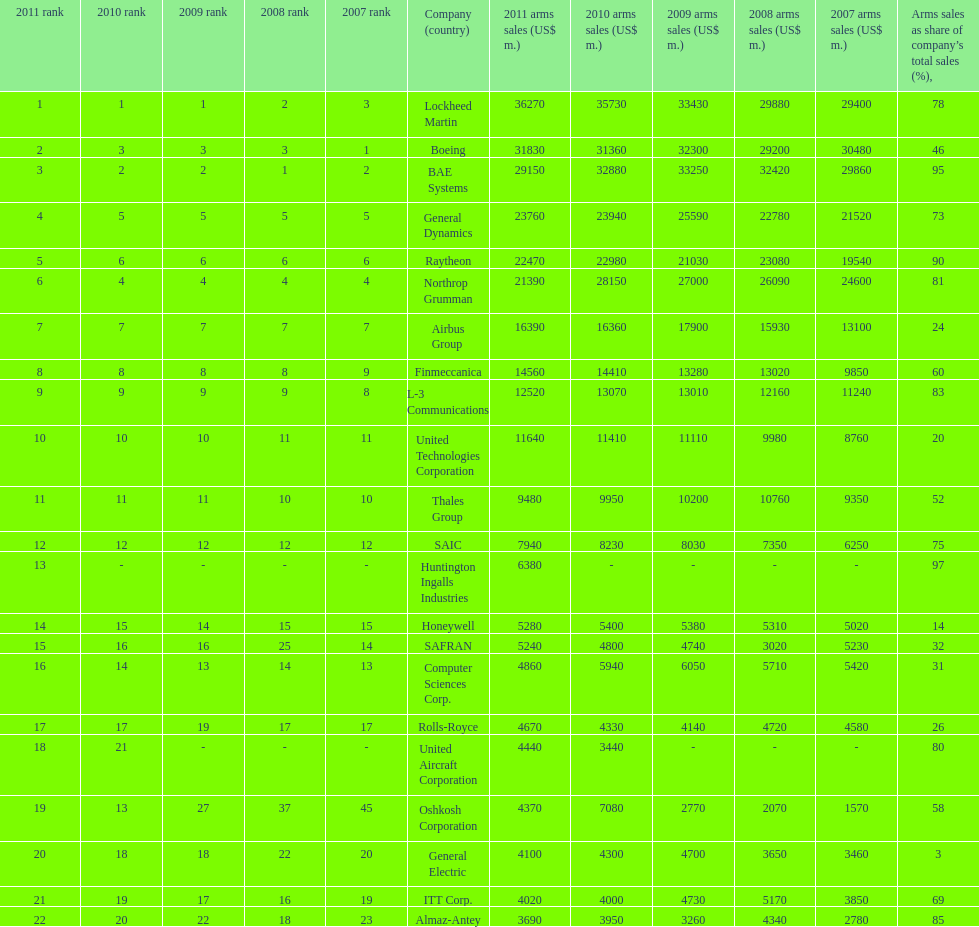Who had the minimum sales in 2010? United Aircraft Corporation. Could you help me parse every detail presented in this table? {'header': ['2011 rank', '2010 rank', '2009 rank', '2008 rank', '2007 rank', 'Company (country)', '2011 arms sales (US$ m.)', '2010 arms sales (US$ m.)', '2009 arms sales (US$ m.)', '2008 arms sales (US$ m.)', '2007 arms sales (US$ m.)', 'Arms sales as share of company’s total sales (%),'], 'rows': [['1', '1', '1', '2', '3', 'Lockheed Martin', '36270', '35730', '33430', '29880', '29400', '78'], ['2', '3', '3', '3', '1', 'Boeing', '31830', '31360', '32300', '29200', '30480', '46'], ['3', '2', '2', '1', '2', 'BAE Systems', '29150', '32880', '33250', '32420', '29860', '95'], ['4', '5', '5', '5', '5', 'General Dynamics', '23760', '23940', '25590', '22780', '21520', '73'], ['5', '6', '6', '6', '6', 'Raytheon', '22470', '22980', '21030', '23080', '19540', '90'], ['6', '4', '4', '4', '4', 'Northrop Grumman', '21390', '28150', '27000', '26090', '24600', '81'], ['7', '7', '7', '7', '7', 'Airbus Group', '16390', '16360', '17900', '15930', '13100', '24'], ['8', '8', '8', '8', '9', 'Finmeccanica', '14560', '14410', '13280', '13020', '9850', '60'], ['9', '9', '9', '9', '8', 'L-3 Communications', '12520', '13070', '13010', '12160', '11240', '83'], ['10', '10', '10', '11', '11', 'United Technologies Corporation', '11640', '11410', '11110', '9980', '8760', '20'], ['11', '11', '11', '10', '10', 'Thales Group', '9480', '9950', '10200', '10760', '9350', '52'], ['12', '12', '12', '12', '12', 'SAIC', '7940', '8230', '8030', '7350', '6250', '75'], ['13', '-', '-', '-', '-', 'Huntington Ingalls Industries', '6380', '-', '-', '-', '-', '97'], ['14', '15', '14', '15', '15', 'Honeywell', '5280', '5400', '5380', '5310', '5020', '14'], ['15', '16', '16', '25', '14', 'SAFRAN', '5240', '4800', '4740', '3020', '5230', '32'], ['16', '14', '13', '14', '13', 'Computer Sciences Corp.', '4860', '5940', '6050', '5710', '5420', '31'], ['17', '17', '19', '17', '17', 'Rolls-Royce', '4670', '4330', '4140', '4720', '4580', '26'], ['18', '21', '-', '-', '-', 'United Aircraft Corporation', '4440', '3440', '-', '-', '-', '80'], ['19', '13', '27', '37', '45', 'Oshkosh Corporation', '4370', '7080', '2770', '2070', '1570', '58'], ['20', '18', '18', '22', '20', 'General Electric', '4100', '4300', '4700', '3650', '3460', '3'], ['21', '19', '17', '16', '19', 'ITT Corp.', '4020', '4000', '4730', '5170', '3850', '69'], ['22', '20', '22', '18', '23', 'Almaz-Antey', '3690', '3950', '3260', '4340', '2780', '85']]} 